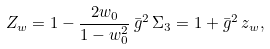<formula> <loc_0><loc_0><loc_500><loc_500>Z _ { w } = 1 - \frac { 2 w _ { 0 } } { 1 - w _ { 0 } ^ { 2 } } \, \bar { g } ^ { 2 } \, \Sigma _ { 3 } = 1 + \bar { g } ^ { 2 } \, z _ { w } ,</formula> 